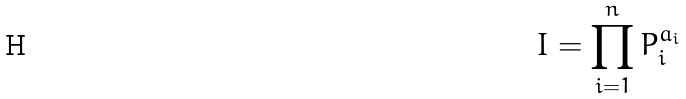<formula> <loc_0><loc_0><loc_500><loc_500>I = \prod _ { i = 1 } ^ { n } P _ { i } ^ { a _ { i } }</formula> 